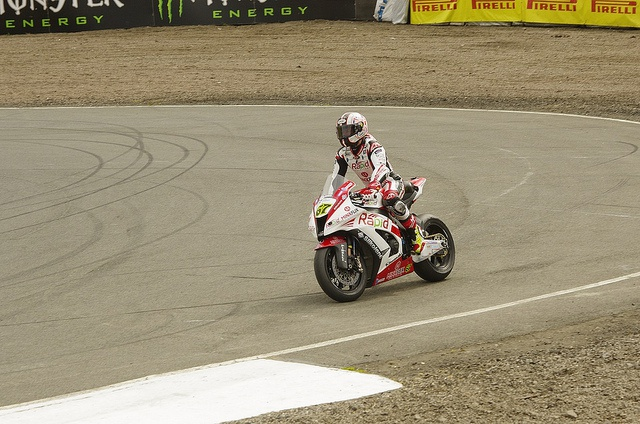Describe the objects in this image and their specific colors. I can see motorcycle in darkgray, black, lightgray, and gray tones and people in darkgray, black, lightgray, and gray tones in this image. 